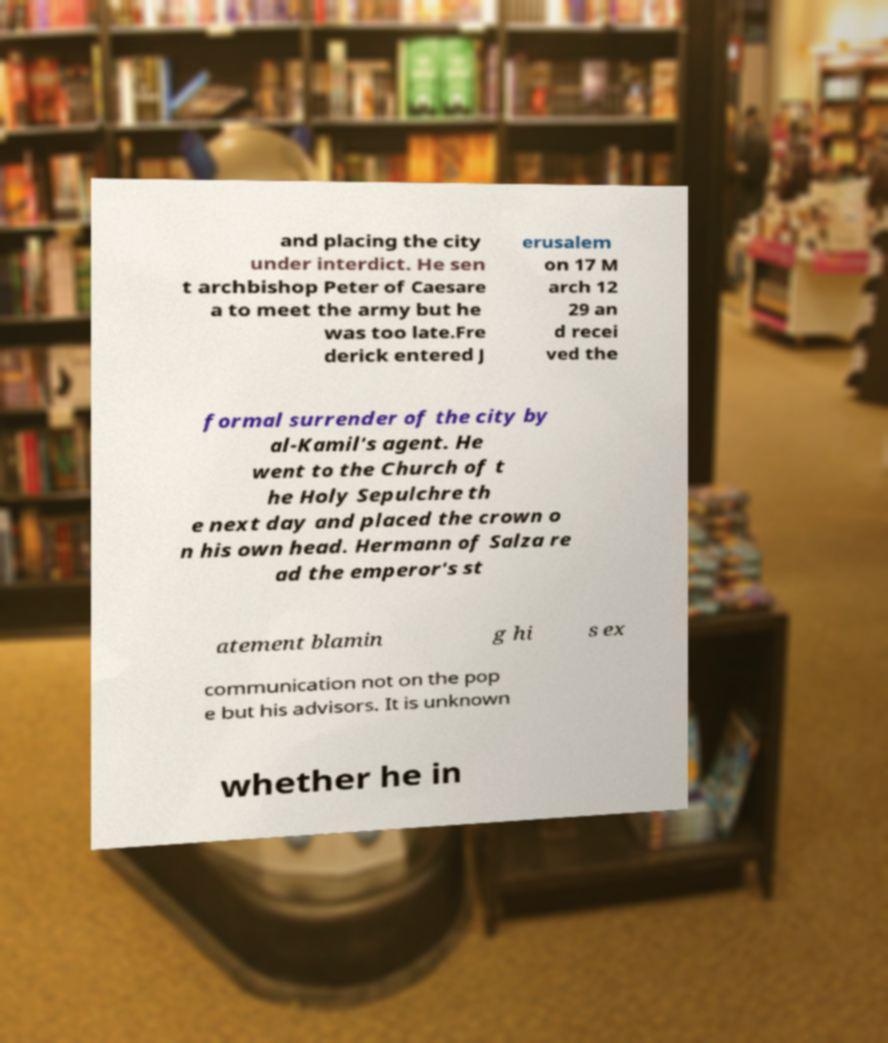Could you assist in decoding the text presented in this image and type it out clearly? and placing the city under interdict. He sen t archbishop Peter of Caesare a to meet the army but he was too late.Fre derick entered J erusalem on 17 M arch 12 29 an d recei ved the formal surrender of the city by al-Kamil's agent. He went to the Church of t he Holy Sepulchre th e next day and placed the crown o n his own head. Hermann of Salza re ad the emperor's st atement blamin g hi s ex communication not on the pop e but his advisors. It is unknown whether he in 